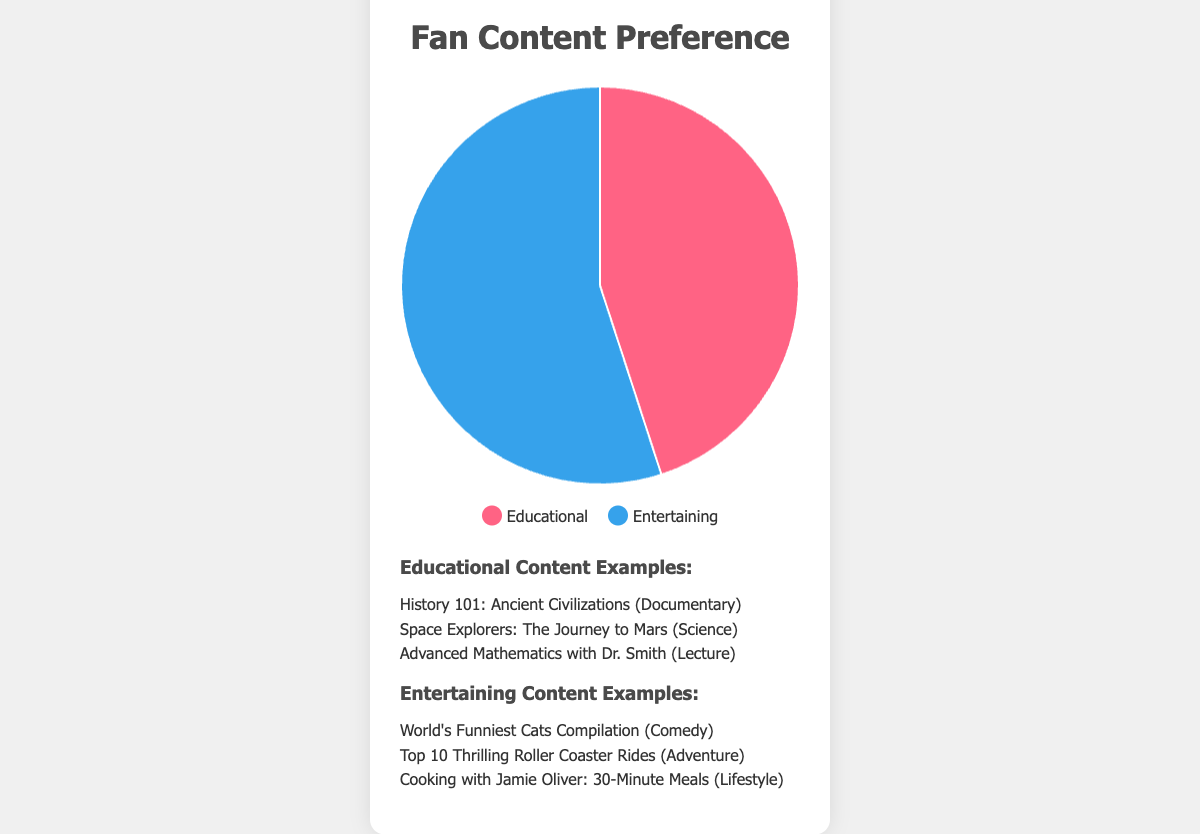What are the percentages of fans who prefer Educational vs. Entertaining content? The pie chart shows a breakdown with Educational content representing 45% and Entertaining content representing 55% of fan preferences.
Answer: Educational: 45%, Entertaining: 55% Which type of content is more popular among fans? By comparing the percentages, Entertaining content (55%) is more popular than Educational content (45%).
Answer: Entertaining What color represents Entertaining content? In the pie chart, Entertaining content is represented by the color blue.
Answer: Blue How much more popular is Entertaining content compared to Educational content? Subtract the percentage of Educational content (45%) from the percentage of Entertaining content (55%) to find the difference: 55% - 45% = 10%.
Answer: 10% What are some examples of Educational content mentioned? The examples listed for Educational content include "History 101: Ancient Civilizations" (Documentary), "Space Explorers: The Journey to Mars" (Science), and "Advanced Mathematics with Dr. Smith" (Lecture).
Answer: History 101: Ancient Civilizations, Space Explorers: The Journey to Mars, Advanced Mathematics with Dr. Smith If you combine the percentages of both types of content, what do you get? Add the percentages of Educational content (45%) and Entertaining content (55%) together: 45% + 55% = 100%.
Answer: 100% What category does "Cooking with Jamie Oliver: 30-Minute Meals" fall under? The pie chart provides examples of Entertaining content, and "Cooking with Jamie Oliver: 30-Minute Meals" is listed under the Lifestyle category.
Answer: Lifestyle What is the least represented category in the list of examples for Entertaining content? The examples of Entertaining content include Comedy, Adventure, and Lifestyle. Each is mentioned once, so none is less represented than the others.
Answer: None What does the red color in the chart represent? In the pie chart, the red color is used to represent Educational content.
Answer: Educational Which category under Educational content involves advanced mathematical concepts? The example "Advanced Mathematics with Dr. Smith" falls under the Lecture category and involves advanced mathematical concepts.
Answer: Lecture 